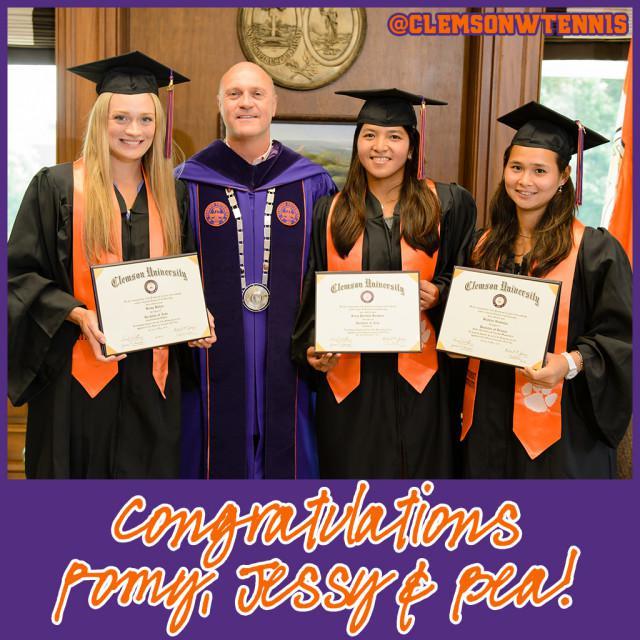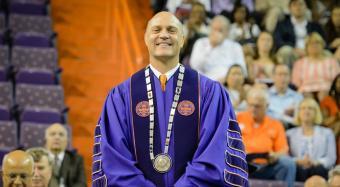The first image is the image on the left, the second image is the image on the right. For the images displayed, is the sentence "One image includes at least two female graduates wearing black caps and robes with orange sashes, and the other image shows only one person in a graduate robe in the foreground." factually correct? Answer yes or no. Yes. The first image is the image on the left, the second image is the image on the right. For the images displayed, is the sentence "There are at least two women wearing orange sashes." factually correct? Answer yes or no. Yes. 